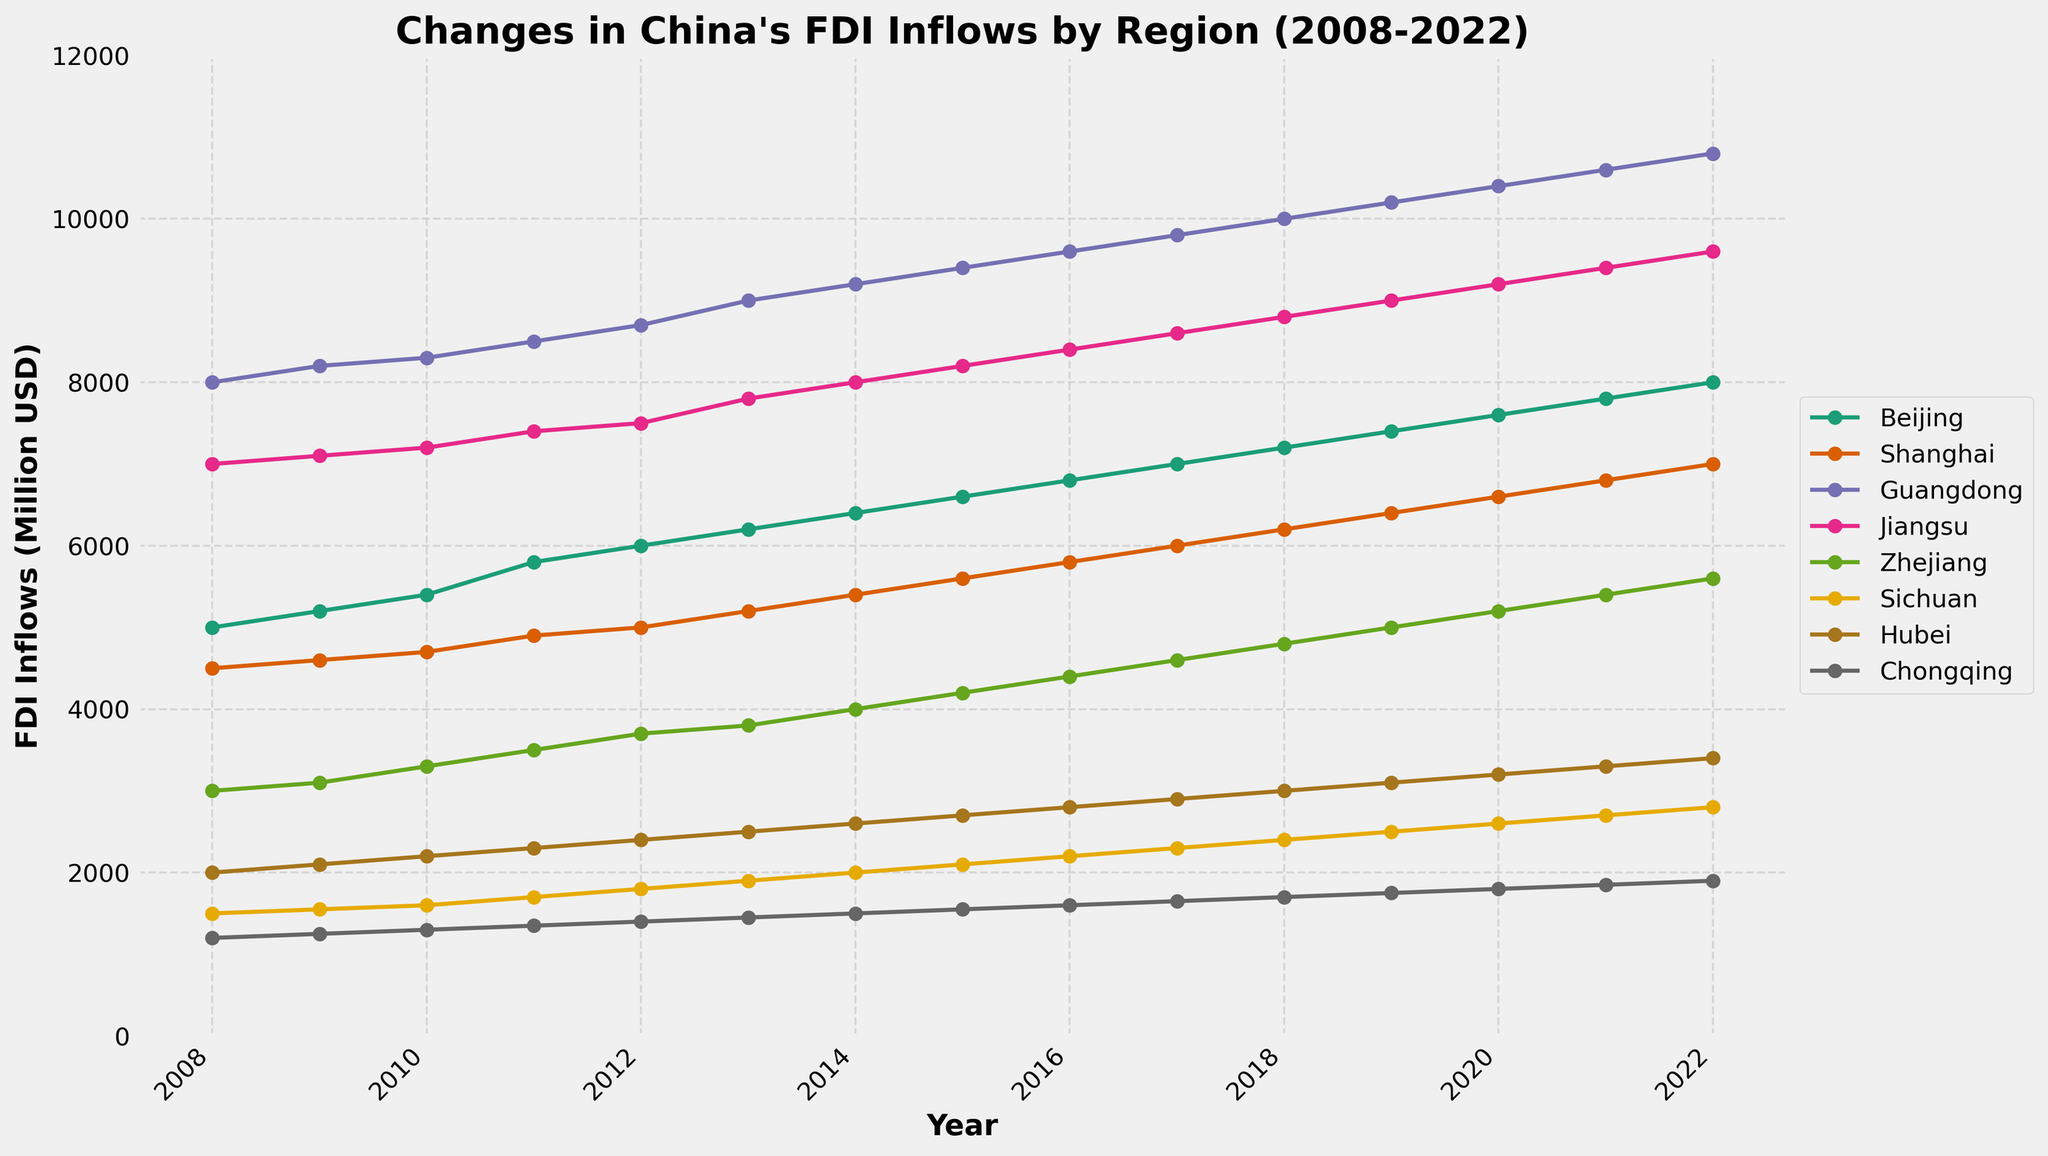What is the title of the plot? The title of the plot is displayed at the top and summarizes the data represented in the figure.
Answer: Changes in China's FDI Inflows by Region (2008-2022) Which region had the highest FDI inflows in 2022? By observing the data points for 2022, we can see which line reaches the highest value. The plot indicates Guangdong has the highest value.
Answer: Guangdong How did the FDI inflows in Beijing change from 2008 to 2022? Look at the data points for Beijing in 2008 and 2022, and compare the values. Beijing's FDI inflows increased from 5000 million USD in 2008 to 8000 million USD in 2022.
Answer: Increased from 5000 to 8000 million USD Which two regions had the closest FDI inflows in 2015? Check the data points for each region in 2015 and find the two regions with the smallest difference in FDI inflows. Sichuan and Hubei both had 2100 and 2700 million USD respectively, making them the closest in value.
Answer: Sichuan and Hubei What was the total FDI inflow in Jiangsu from 2008 to 2022? Sum up the values of FDI inflows in Jiangsu from 2008 to 2022: 7000 + 7100 + 7200 + 7400 + 7500 + 7800 + 8000 + 8200 + 8400 + 8600 + 8800 + 9000 + 9200 + 9400 + 9600.
Answer: 103600 million USD Which region showed the most significant increase in FDI inflows over the period 2008-2022? Calculate the difference between the FDI inflows in 2022 and 2008 for each region and identify the region with the largest increase. Guangdong's FDI inflows increased from 8000 to 10800 million USD, which is the largest increase of 2800 million USD.
Answer: Guangdong How did FDI inflows in Zhejiang and Chongqing compare in 2010? Check and compare the data points for Zhejiang and Chongqing in 2010. Zhejiang had 3300 million USD and Chongqing had 1300 million USD. Zhejiang had higher FDI inflows.
Answer: Zhejiang had higher What is the average FDI inflow for Shanghai over the 15 years? Calculate the average by summing up the FDI inflows for Shanghai from 2008 to 2022 and dividing by 15 (the number of years). Sum = 4500 + 4600 + 4700 + 4900 + 5000 + 5200 + 5400 + 5600 + 5800 + 6000 + 6200 + 6400 + 6600 + 6800 + 7000 = 80900. Average = 80900 / 15.
Answer: Approx. 5393.33 million USD In which year did Sichuan's FDI inflows exceed 2000 million USD for the first time? Look for the year in which the value of Sichuan’s FDI inflows surpassed 2000 million USD in the plot. This happened in 2014.
Answer: 2014 